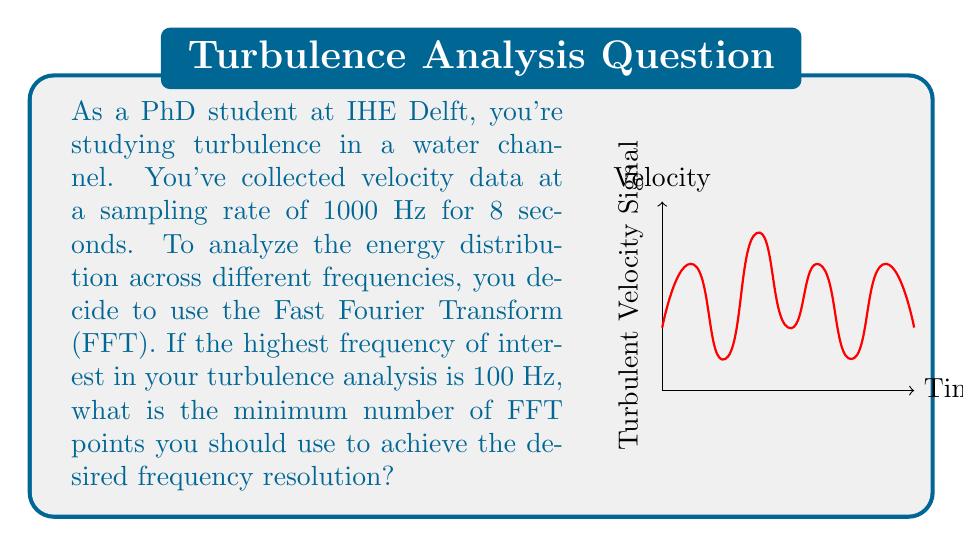Teach me how to tackle this problem. Let's approach this step-by-step:

1) First, we need to determine the total number of data points:
   Sampling rate = 1000 Hz
   Duration = 8 seconds
   Total data points = $1000 \times 8 = 8000$

2) The frequency resolution of the FFT is given by:
   $$\Delta f = \frac{f_s}{N_{FFT}}$$
   where $f_s$ is the sampling frequency and $N_{FFT}$ is the number of FFT points.

3) We want to resolve frequencies up to 100 Hz. To do this effectively, we need at least two points per cycle at the highest frequency of interest. This means our frequency resolution should be at least:
   $$\Delta f \leq \frac{100 \text{ Hz}}{2} = 50 \text{ Hz}$$

4) Substituting this into our frequency resolution equation:
   $$50 \text{ Hz} \geq \frac{1000 \text{ Hz}}{N_{FFT}}$$

5) Solving for $N_{FFT}$:
   $$N_{FFT} \geq \frac{1000 \text{ Hz}}{50 \text{ Hz}} = 20$$

6) However, for the FFT to be efficient, $N_{FFT}$ should be a power of 2. The next power of 2 greater than 20 is 32.

7) We also need to ensure that $N_{FFT}$ is not greater than our total number of data points (8000). 32 is well below this limit.

Therefore, the minimum number of FFT points we should use is 32.
Answer: 32 points 